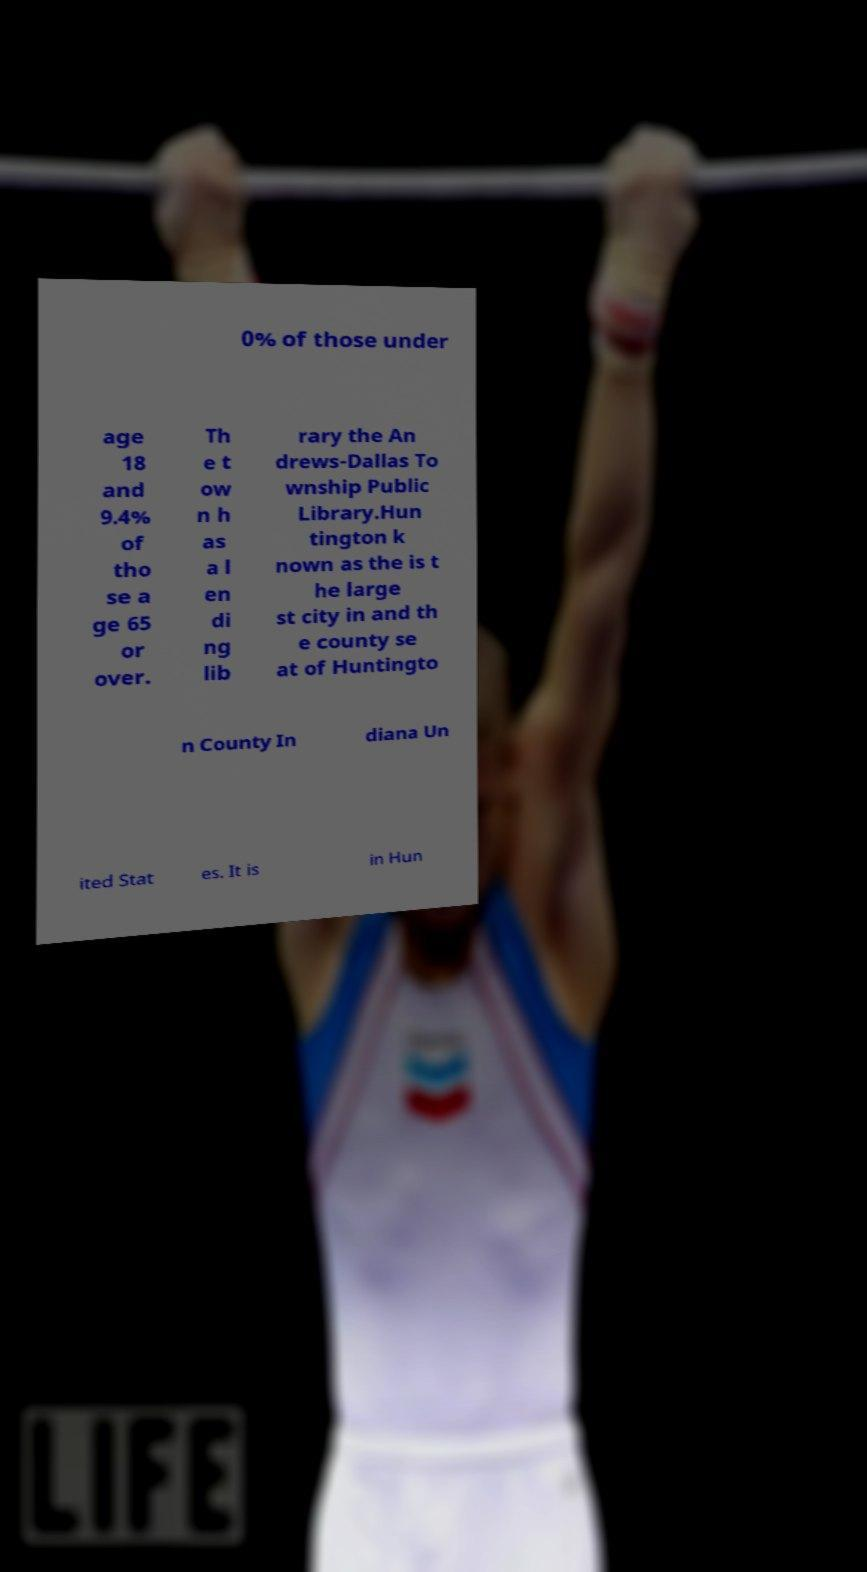Please identify and transcribe the text found in this image. 0% of those under age 18 and 9.4% of tho se a ge 65 or over. Th e t ow n h as a l en di ng lib rary the An drews-Dallas To wnship Public Library.Hun tington k nown as the is t he large st city in and th e county se at of Huntingto n County In diana Un ited Stat es. It is in Hun 